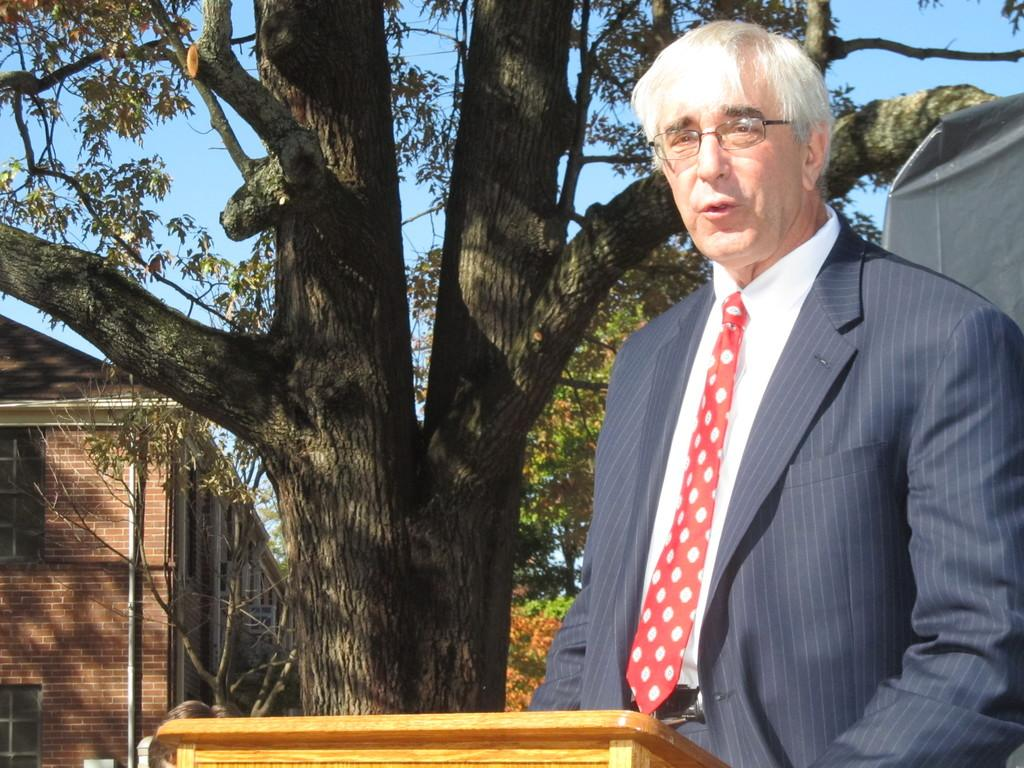Who or what is present in the image? There is a person in the image. What type of texture can be seen in the image? There is a wooden texture in the image. What can be seen in the background of the image? There are buildings, poles, trees, and the sky visible in the background of the image. What letters are being spelled out by the pear in the image? There is no pear present in the image, and therefore no letters can be spelled out by it. 